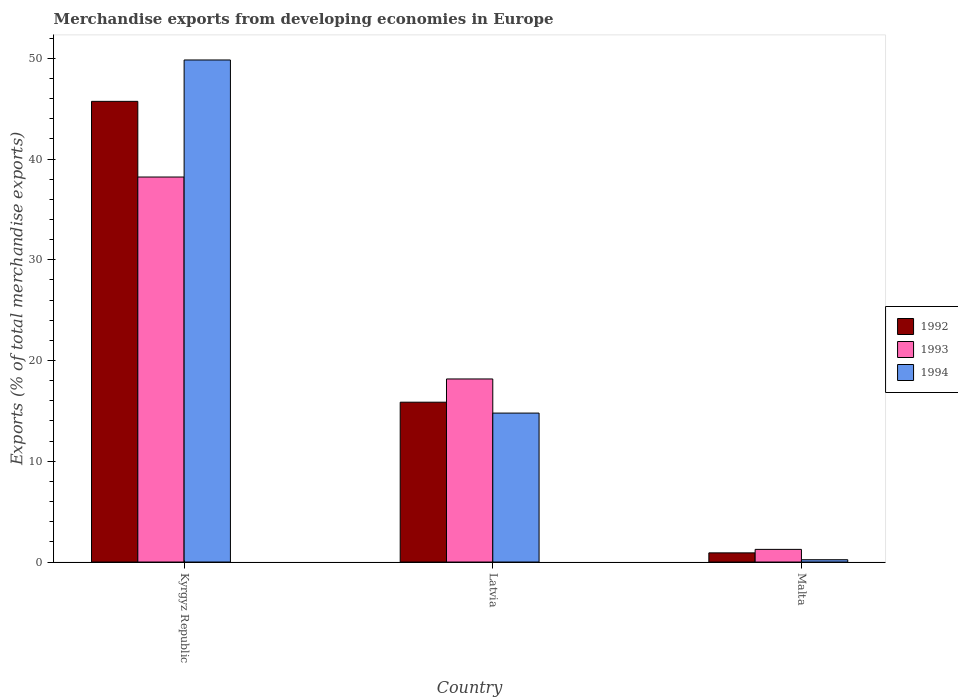How many different coloured bars are there?
Provide a short and direct response. 3. How many groups of bars are there?
Offer a terse response. 3. How many bars are there on the 3rd tick from the left?
Ensure brevity in your answer.  3. What is the label of the 1st group of bars from the left?
Your response must be concise. Kyrgyz Republic. In how many cases, is the number of bars for a given country not equal to the number of legend labels?
Make the answer very short. 0. What is the percentage of total merchandise exports in 1994 in Latvia?
Provide a short and direct response. 14.79. Across all countries, what is the maximum percentage of total merchandise exports in 1994?
Ensure brevity in your answer.  49.84. Across all countries, what is the minimum percentage of total merchandise exports in 1992?
Provide a short and direct response. 0.91. In which country was the percentage of total merchandise exports in 1992 maximum?
Your answer should be very brief. Kyrgyz Republic. In which country was the percentage of total merchandise exports in 1992 minimum?
Make the answer very short. Malta. What is the total percentage of total merchandise exports in 1994 in the graph?
Offer a very short reply. 64.85. What is the difference between the percentage of total merchandise exports in 1992 in Kyrgyz Republic and that in Malta?
Ensure brevity in your answer.  44.82. What is the difference between the percentage of total merchandise exports in 1993 in Latvia and the percentage of total merchandise exports in 1992 in Malta?
Provide a short and direct response. 17.26. What is the average percentage of total merchandise exports in 1993 per country?
Make the answer very short. 19.22. What is the difference between the percentage of total merchandise exports of/in 1994 and percentage of total merchandise exports of/in 1993 in Kyrgyz Republic?
Make the answer very short. 11.62. In how many countries, is the percentage of total merchandise exports in 1993 greater than 28 %?
Ensure brevity in your answer.  1. What is the ratio of the percentage of total merchandise exports in 1994 in Kyrgyz Republic to that in Latvia?
Provide a succinct answer. 3.37. Is the percentage of total merchandise exports in 1992 in Latvia less than that in Malta?
Your answer should be very brief. No. What is the difference between the highest and the second highest percentage of total merchandise exports in 1993?
Keep it short and to the point. -16.92. What is the difference between the highest and the lowest percentage of total merchandise exports in 1994?
Provide a succinct answer. 49.61. In how many countries, is the percentage of total merchandise exports in 1993 greater than the average percentage of total merchandise exports in 1993 taken over all countries?
Provide a succinct answer. 1. What does the 2nd bar from the left in Latvia represents?
Ensure brevity in your answer.  1993. Is it the case that in every country, the sum of the percentage of total merchandise exports in 1994 and percentage of total merchandise exports in 1993 is greater than the percentage of total merchandise exports in 1992?
Keep it short and to the point. Yes. Are all the bars in the graph horizontal?
Offer a terse response. No. How many countries are there in the graph?
Give a very brief answer. 3. Does the graph contain any zero values?
Offer a terse response. No. Where does the legend appear in the graph?
Your answer should be very brief. Center right. How are the legend labels stacked?
Provide a succinct answer. Vertical. What is the title of the graph?
Your answer should be very brief. Merchandise exports from developing economies in Europe. What is the label or title of the Y-axis?
Make the answer very short. Exports (% of total merchandise exports). What is the Exports (% of total merchandise exports) in 1992 in Kyrgyz Republic?
Provide a succinct answer. 45.73. What is the Exports (% of total merchandise exports) in 1993 in Kyrgyz Republic?
Offer a terse response. 38.22. What is the Exports (% of total merchandise exports) in 1994 in Kyrgyz Republic?
Your answer should be compact. 49.84. What is the Exports (% of total merchandise exports) of 1992 in Latvia?
Provide a succinct answer. 15.87. What is the Exports (% of total merchandise exports) of 1993 in Latvia?
Offer a terse response. 18.17. What is the Exports (% of total merchandise exports) of 1994 in Latvia?
Offer a very short reply. 14.79. What is the Exports (% of total merchandise exports) in 1992 in Malta?
Offer a very short reply. 0.91. What is the Exports (% of total merchandise exports) of 1993 in Malta?
Your answer should be very brief. 1.26. What is the Exports (% of total merchandise exports) of 1994 in Malta?
Your answer should be very brief. 0.23. Across all countries, what is the maximum Exports (% of total merchandise exports) in 1992?
Ensure brevity in your answer.  45.73. Across all countries, what is the maximum Exports (% of total merchandise exports) of 1993?
Keep it short and to the point. 38.22. Across all countries, what is the maximum Exports (% of total merchandise exports) in 1994?
Your answer should be very brief. 49.84. Across all countries, what is the minimum Exports (% of total merchandise exports) of 1992?
Your answer should be very brief. 0.91. Across all countries, what is the minimum Exports (% of total merchandise exports) of 1993?
Ensure brevity in your answer.  1.26. Across all countries, what is the minimum Exports (% of total merchandise exports) of 1994?
Ensure brevity in your answer.  0.23. What is the total Exports (% of total merchandise exports) of 1992 in the graph?
Provide a short and direct response. 62.5. What is the total Exports (% of total merchandise exports) in 1993 in the graph?
Offer a very short reply. 57.65. What is the total Exports (% of total merchandise exports) in 1994 in the graph?
Provide a succinct answer. 64.85. What is the difference between the Exports (% of total merchandise exports) in 1992 in Kyrgyz Republic and that in Latvia?
Your answer should be compact. 29.86. What is the difference between the Exports (% of total merchandise exports) of 1993 in Kyrgyz Republic and that in Latvia?
Your answer should be very brief. 20.04. What is the difference between the Exports (% of total merchandise exports) in 1994 in Kyrgyz Republic and that in Latvia?
Your answer should be compact. 35.05. What is the difference between the Exports (% of total merchandise exports) in 1992 in Kyrgyz Republic and that in Malta?
Offer a very short reply. 44.82. What is the difference between the Exports (% of total merchandise exports) in 1993 in Kyrgyz Republic and that in Malta?
Provide a short and direct response. 36.96. What is the difference between the Exports (% of total merchandise exports) in 1994 in Kyrgyz Republic and that in Malta?
Provide a short and direct response. 49.61. What is the difference between the Exports (% of total merchandise exports) in 1992 in Latvia and that in Malta?
Offer a terse response. 14.96. What is the difference between the Exports (% of total merchandise exports) of 1993 in Latvia and that in Malta?
Offer a very short reply. 16.92. What is the difference between the Exports (% of total merchandise exports) of 1994 in Latvia and that in Malta?
Keep it short and to the point. 14.56. What is the difference between the Exports (% of total merchandise exports) in 1992 in Kyrgyz Republic and the Exports (% of total merchandise exports) in 1993 in Latvia?
Offer a terse response. 27.56. What is the difference between the Exports (% of total merchandise exports) of 1992 in Kyrgyz Republic and the Exports (% of total merchandise exports) of 1994 in Latvia?
Offer a very short reply. 30.94. What is the difference between the Exports (% of total merchandise exports) of 1993 in Kyrgyz Republic and the Exports (% of total merchandise exports) of 1994 in Latvia?
Your answer should be compact. 23.43. What is the difference between the Exports (% of total merchandise exports) of 1992 in Kyrgyz Republic and the Exports (% of total merchandise exports) of 1993 in Malta?
Offer a terse response. 44.47. What is the difference between the Exports (% of total merchandise exports) of 1992 in Kyrgyz Republic and the Exports (% of total merchandise exports) of 1994 in Malta?
Offer a terse response. 45.5. What is the difference between the Exports (% of total merchandise exports) in 1993 in Kyrgyz Republic and the Exports (% of total merchandise exports) in 1994 in Malta?
Keep it short and to the point. 37.99. What is the difference between the Exports (% of total merchandise exports) in 1992 in Latvia and the Exports (% of total merchandise exports) in 1993 in Malta?
Provide a short and direct response. 14.61. What is the difference between the Exports (% of total merchandise exports) in 1992 in Latvia and the Exports (% of total merchandise exports) in 1994 in Malta?
Keep it short and to the point. 15.64. What is the difference between the Exports (% of total merchandise exports) in 1993 in Latvia and the Exports (% of total merchandise exports) in 1994 in Malta?
Provide a short and direct response. 17.94. What is the average Exports (% of total merchandise exports) of 1992 per country?
Provide a succinct answer. 20.84. What is the average Exports (% of total merchandise exports) of 1993 per country?
Ensure brevity in your answer.  19.22. What is the average Exports (% of total merchandise exports) in 1994 per country?
Your answer should be very brief. 21.62. What is the difference between the Exports (% of total merchandise exports) of 1992 and Exports (% of total merchandise exports) of 1993 in Kyrgyz Republic?
Offer a terse response. 7.51. What is the difference between the Exports (% of total merchandise exports) in 1992 and Exports (% of total merchandise exports) in 1994 in Kyrgyz Republic?
Provide a short and direct response. -4.11. What is the difference between the Exports (% of total merchandise exports) in 1993 and Exports (% of total merchandise exports) in 1994 in Kyrgyz Republic?
Your answer should be compact. -11.62. What is the difference between the Exports (% of total merchandise exports) of 1992 and Exports (% of total merchandise exports) of 1993 in Latvia?
Your answer should be compact. -2.31. What is the difference between the Exports (% of total merchandise exports) in 1992 and Exports (% of total merchandise exports) in 1994 in Latvia?
Give a very brief answer. 1.08. What is the difference between the Exports (% of total merchandise exports) of 1993 and Exports (% of total merchandise exports) of 1994 in Latvia?
Your answer should be very brief. 3.39. What is the difference between the Exports (% of total merchandise exports) of 1992 and Exports (% of total merchandise exports) of 1993 in Malta?
Provide a succinct answer. -0.34. What is the difference between the Exports (% of total merchandise exports) of 1992 and Exports (% of total merchandise exports) of 1994 in Malta?
Give a very brief answer. 0.68. What is the difference between the Exports (% of total merchandise exports) of 1993 and Exports (% of total merchandise exports) of 1994 in Malta?
Your response must be concise. 1.03. What is the ratio of the Exports (% of total merchandise exports) in 1992 in Kyrgyz Republic to that in Latvia?
Offer a terse response. 2.88. What is the ratio of the Exports (% of total merchandise exports) of 1993 in Kyrgyz Republic to that in Latvia?
Keep it short and to the point. 2.1. What is the ratio of the Exports (% of total merchandise exports) in 1994 in Kyrgyz Republic to that in Latvia?
Your answer should be very brief. 3.37. What is the ratio of the Exports (% of total merchandise exports) of 1992 in Kyrgyz Republic to that in Malta?
Offer a terse response. 50.24. What is the ratio of the Exports (% of total merchandise exports) of 1993 in Kyrgyz Republic to that in Malta?
Keep it short and to the point. 30.45. What is the ratio of the Exports (% of total merchandise exports) in 1994 in Kyrgyz Republic to that in Malta?
Give a very brief answer. 217.01. What is the ratio of the Exports (% of total merchandise exports) in 1992 in Latvia to that in Malta?
Offer a very short reply. 17.43. What is the ratio of the Exports (% of total merchandise exports) in 1993 in Latvia to that in Malta?
Your answer should be compact. 14.48. What is the ratio of the Exports (% of total merchandise exports) of 1994 in Latvia to that in Malta?
Offer a terse response. 64.38. What is the difference between the highest and the second highest Exports (% of total merchandise exports) in 1992?
Provide a succinct answer. 29.86. What is the difference between the highest and the second highest Exports (% of total merchandise exports) of 1993?
Provide a succinct answer. 20.04. What is the difference between the highest and the second highest Exports (% of total merchandise exports) in 1994?
Offer a very short reply. 35.05. What is the difference between the highest and the lowest Exports (% of total merchandise exports) of 1992?
Make the answer very short. 44.82. What is the difference between the highest and the lowest Exports (% of total merchandise exports) in 1993?
Make the answer very short. 36.96. What is the difference between the highest and the lowest Exports (% of total merchandise exports) in 1994?
Keep it short and to the point. 49.61. 